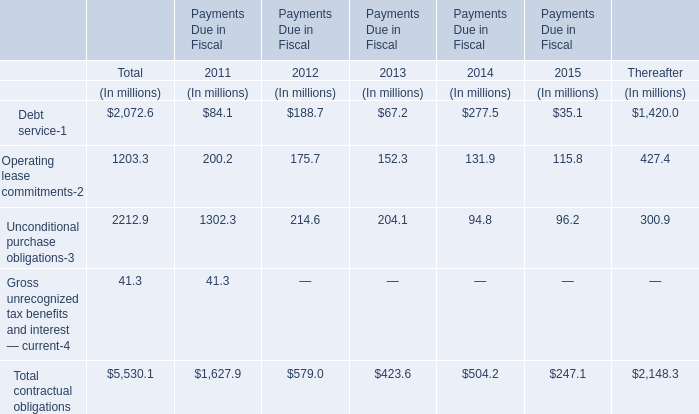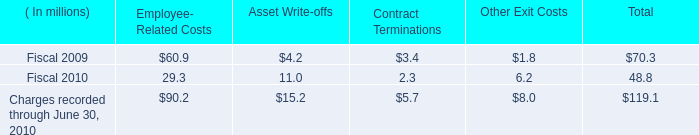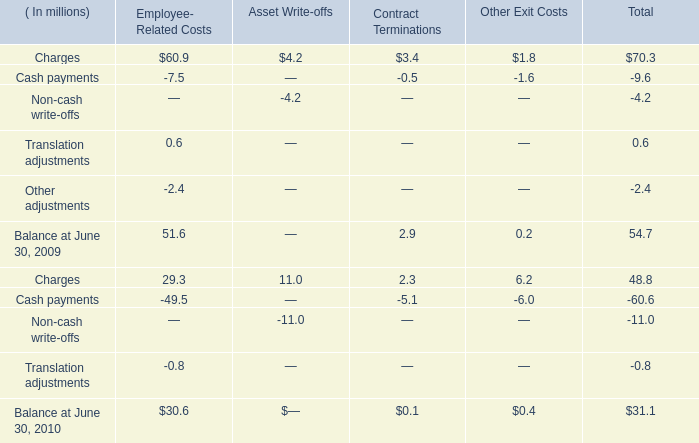What was the sum of Asset Write-offs without those Asset Write-offs smaller than 0? (in million) 
Computations: (4.2 + 11.0)
Answer: 15.2. 